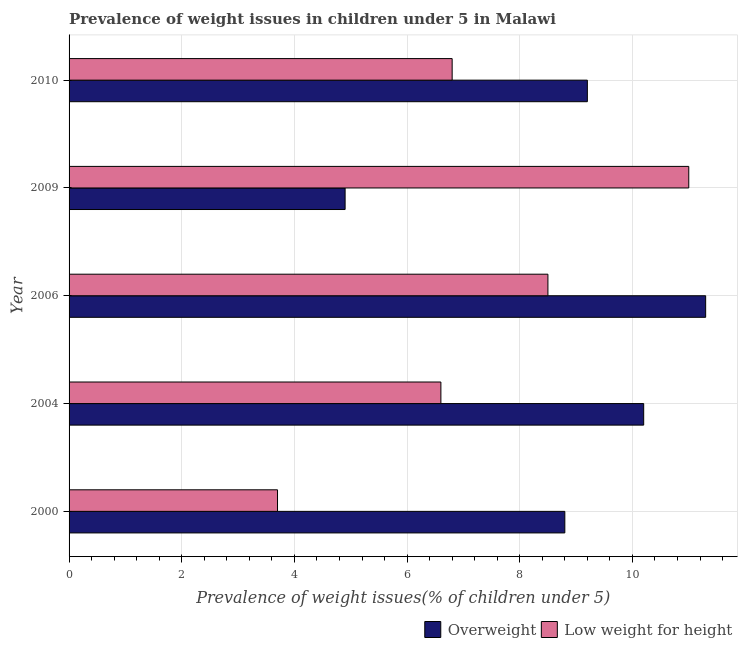How many different coloured bars are there?
Your answer should be very brief. 2. Are the number of bars on each tick of the Y-axis equal?
Ensure brevity in your answer.  Yes. How many bars are there on the 5th tick from the top?
Give a very brief answer. 2. What is the percentage of overweight children in 2006?
Make the answer very short. 11.3. Across all years, what is the maximum percentage of overweight children?
Provide a succinct answer. 11.3. Across all years, what is the minimum percentage of underweight children?
Make the answer very short. 3.7. In which year was the percentage of underweight children maximum?
Offer a very short reply. 2009. In which year was the percentage of underweight children minimum?
Keep it short and to the point. 2000. What is the total percentage of overweight children in the graph?
Your answer should be compact. 44.4. What is the difference between the percentage of overweight children in 2004 and the percentage of underweight children in 2010?
Your response must be concise. 3.4. What is the average percentage of overweight children per year?
Give a very brief answer. 8.88. What is the ratio of the percentage of overweight children in 2000 to that in 2004?
Offer a very short reply. 0.86. What is the difference between the highest and the second highest percentage of overweight children?
Ensure brevity in your answer.  1.1. What does the 1st bar from the top in 2009 represents?
Provide a short and direct response. Low weight for height. What does the 1st bar from the bottom in 2004 represents?
Ensure brevity in your answer.  Overweight. How many years are there in the graph?
Give a very brief answer. 5. What is the difference between two consecutive major ticks on the X-axis?
Provide a short and direct response. 2. Are the values on the major ticks of X-axis written in scientific E-notation?
Make the answer very short. No. Does the graph contain any zero values?
Offer a terse response. No. How are the legend labels stacked?
Make the answer very short. Horizontal. What is the title of the graph?
Your response must be concise. Prevalence of weight issues in children under 5 in Malawi. What is the label or title of the X-axis?
Ensure brevity in your answer.  Prevalence of weight issues(% of children under 5). What is the Prevalence of weight issues(% of children under 5) of Overweight in 2000?
Keep it short and to the point. 8.8. What is the Prevalence of weight issues(% of children under 5) in Low weight for height in 2000?
Make the answer very short. 3.7. What is the Prevalence of weight issues(% of children under 5) in Overweight in 2004?
Offer a very short reply. 10.2. What is the Prevalence of weight issues(% of children under 5) of Low weight for height in 2004?
Your answer should be compact. 6.6. What is the Prevalence of weight issues(% of children under 5) in Overweight in 2006?
Offer a terse response. 11.3. What is the Prevalence of weight issues(% of children under 5) in Overweight in 2009?
Offer a terse response. 4.9. What is the Prevalence of weight issues(% of children under 5) in Low weight for height in 2009?
Ensure brevity in your answer.  11. What is the Prevalence of weight issues(% of children under 5) of Overweight in 2010?
Offer a terse response. 9.2. What is the Prevalence of weight issues(% of children under 5) of Low weight for height in 2010?
Provide a short and direct response. 6.8. Across all years, what is the maximum Prevalence of weight issues(% of children under 5) in Overweight?
Make the answer very short. 11.3. Across all years, what is the maximum Prevalence of weight issues(% of children under 5) of Low weight for height?
Make the answer very short. 11. Across all years, what is the minimum Prevalence of weight issues(% of children under 5) of Overweight?
Give a very brief answer. 4.9. Across all years, what is the minimum Prevalence of weight issues(% of children under 5) in Low weight for height?
Your response must be concise. 3.7. What is the total Prevalence of weight issues(% of children under 5) of Overweight in the graph?
Make the answer very short. 44.4. What is the total Prevalence of weight issues(% of children under 5) in Low weight for height in the graph?
Your answer should be very brief. 36.6. What is the difference between the Prevalence of weight issues(% of children under 5) in Overweight in 2000 and that in 2004?
Ensure brevity in your answer.  -1.4. What is the difference between the Prevalence of weight issues(% of children under 5) in Overweight in 2000 and that in 2009?
Your answer should be very brief. 3.9. What is the difference between the Prevalence of weight issues(% of children under 5) in Low weight for height in 2000 and that in 2010?
Ensure brevity in your answer.  -3.1. What is the difference between the Prevalence of weight issues(% of children under 5) in Overweight in 2004 and that in 2009?
Offer a terse response. 5.3. What is the difference between the Prevalence of weight issues(% of children under 5) of Overweight in 2004 and that in 2010?
Give a very brief answer. 1. What is the difference between the Prevalence of weight issues(% of children under 5) of Low weight for height in 2004 and that in 2010?
Provide a short and direct response. -0.2. What is the difference between the Prevalence of weight issues(% of children under 5) of Overweight in 2006 and that in 2009?
Your answer should be compact. 6.4. What is the difference between the Prevalence of weight issues(% of children under 5) of Low weight for height in 2006 and that in 2009?
Make the answer very short. -2.5. What is the difference between the Prevalence of weight issues(% of children under 5) of Overweight in 2006 and that in 2010?
Ensure brevity in your answer.  2.1. What is the difference between the Prevalence of weight issues(% of children under 5) of Low weight for height in 2006 and that in 2010?
Your answer should be compact. 1.7. What is the difference between the Prevalence of weight issues(% of children under 5) of Overweight in 2009 and that in 2010?
Provide a short and direct response. -4.3. What is the difference between the Prevalence of weight issues(% of children under 5) in Overweight in 2000 and the Prevalence of weight issues(% of children under 5) in Low weight for height in 2004?
Keep it short and to the point. 2.2. What is the difference between the Prevalence of weight issues(% of children under 5) in Overweight in 2000 and the Prevalence of weight issues(% of children under 5) in Low weight for height in 2006?
Provide a short and direct response. 0.3. What is the difference between the Prevalence of weight issues(% of children under 5) in Overweight in 2000 and the Prevalence of weight issues(% of children under 5) in Low weight for height in 2010?
Make the answer very short. 2. What is the difference between the Prevalence of weight issues(% of children under 5) of Overweight in 2004 and the Prevalence of weight issues(% of children under 5) of Low weight for height in 2010?
Your answer should be very brief. 3.4. What is the difference between the Prevalence of weight issues(% of children under 5) in Overweight in 2006 and the Prevalence of weight issues(% of children under 5) in Low weight for height in 2010?
Your answer should be compact. 4.5. What is the average Prevalence of weight issues(% of children under 5) of Overweight per year?
Keep it short and to the point. 8.88. What is the average Prevalence of weight issues(% of children under 5) of Low weight for height per year?
Make the answer very short. 7.32. In the year 2000, what is the difference between the Prevalence of weight issues(% of children under 5) of Overweight and Prevalence of weight issues(% of children under 5) of Low weight for height?
Keep it short and to the point. 5.1. In the year 2004, what is the difference between the Prevalence of weight issues(% of children under 5) of Overweight and Prevalence of weight issues(% of children under 5) of Low weight for height?
Provide a succinct answer. 3.6. In the year 2010, what is the difference between the Prevalence of weight issues(% of children under 5) in Overweight and Prevalence of weight issues(% of children under 5) in Low weight for height?
Ensure brevity in your answer.  2.4. What is the ratio of the Prevalence of weight issues(% of children under 5) of Overweight in 2000 to that in 2004?
Give a very brief answer. 0.86. What is the ratio of the Prevalence of weight issues(% of children under 5) in Low weight for height in 2000 to that in 2004?
Keep it short and to the point. 0.56. What is the ratio of the Prevalence of weight issues(% of children under 5) in Overweight in 2000 to that in 2006?
Your answer should be compact. 0.78. What is the ratio of the Prevalence of weight issues(% of children under 5) in Low weight for height in 2000 to that in 2006?
Keep it short and to the point. 0.44. What is the ratio of the Prevalence of weight issues(% of children under 5) of Overweight in 2000 to that in 2009?
Your response must be concise. 1.8. What is the ratio of the Prevalence of weight issues(% of children under 5) of Low weight for height in 2000 to that in 2009?
Your answer should be very brief. 0.34. What is the ratio of the Prevalence of weight issues(% of children under 5) in Overweight in 2000 to that in 2010?
Your response must be concise. 0.96. What is the ratio of the Prevalence of weight issues(% of children under 5) in Low weight for height in 2000 to that in 2010?
Provide a short and direct response. 0.54. What is the ratio of the Prevalence of weight issues(% of children under 5) in Overweight in 2004 to that in 2006?
Provide a succinct answer. 0.9. What is the ratio of the Prevalence of weight issues(% of children under 5) of Low weight for height in 2004 to that in 2006?
Provide a succinct answer. 0.78. What is the ratio of the Prevalence of weight issues(% of children under 5) in Overweight in 2004 to that in 2009?
Make the answer very short. 2.08. What is the ratio of the Prevalence of weight issues(% of children under 5) in Low weight for height in 2004 to that in 2009?
Your response must be concise. 0.6. What is the ratio of the Prevalence of weight issues(% of children under 5) in Overweight in 2004 to that in 2010?
Your response must be concise. 1.11. What is the ratio of the Prevalence of weight issues(% of children under 5) of Low weight for height in 2004 to that in 2010?
Your response must be concise. 0.97. What is the ratio of the Prevalence of weight issues(% of children under 5) of Overweight in 2006 to that in 2009?
Provide a short and direct response. 2.31. What is the ratio of the Prevalence of weight issues(% of children under 5) of Low weight for height in 2006 to that in 2009?
Your answer should be compact. 0.77. What is the ratio of the Prevalence of weight issues(% of children under 5) of Overweight in 2006 to that in 2010?
Offer a terse response. 1.23. What is the ratio of the Prevalence of weight issues(% of children under 5) in Low weight for height in 2006 to that in 2010?
Give a very brief answer. 1.25. What is the ratio of the Prevalence of weight issues(% of children under 5) in Overweight in 2009 to that in 2010?
Provide a succinct answer. 0.53. What is the ratio of the Prevalence of weight issues(% of children under 5) of Low weight for height in 2009 to that in 2010?
Your answer should be compact. 1.62. What is the difference between the highest and the lowest Prevalence of weight issues(% of children under 5) in Low weight for height?
Make the answer very short. 7.3. 